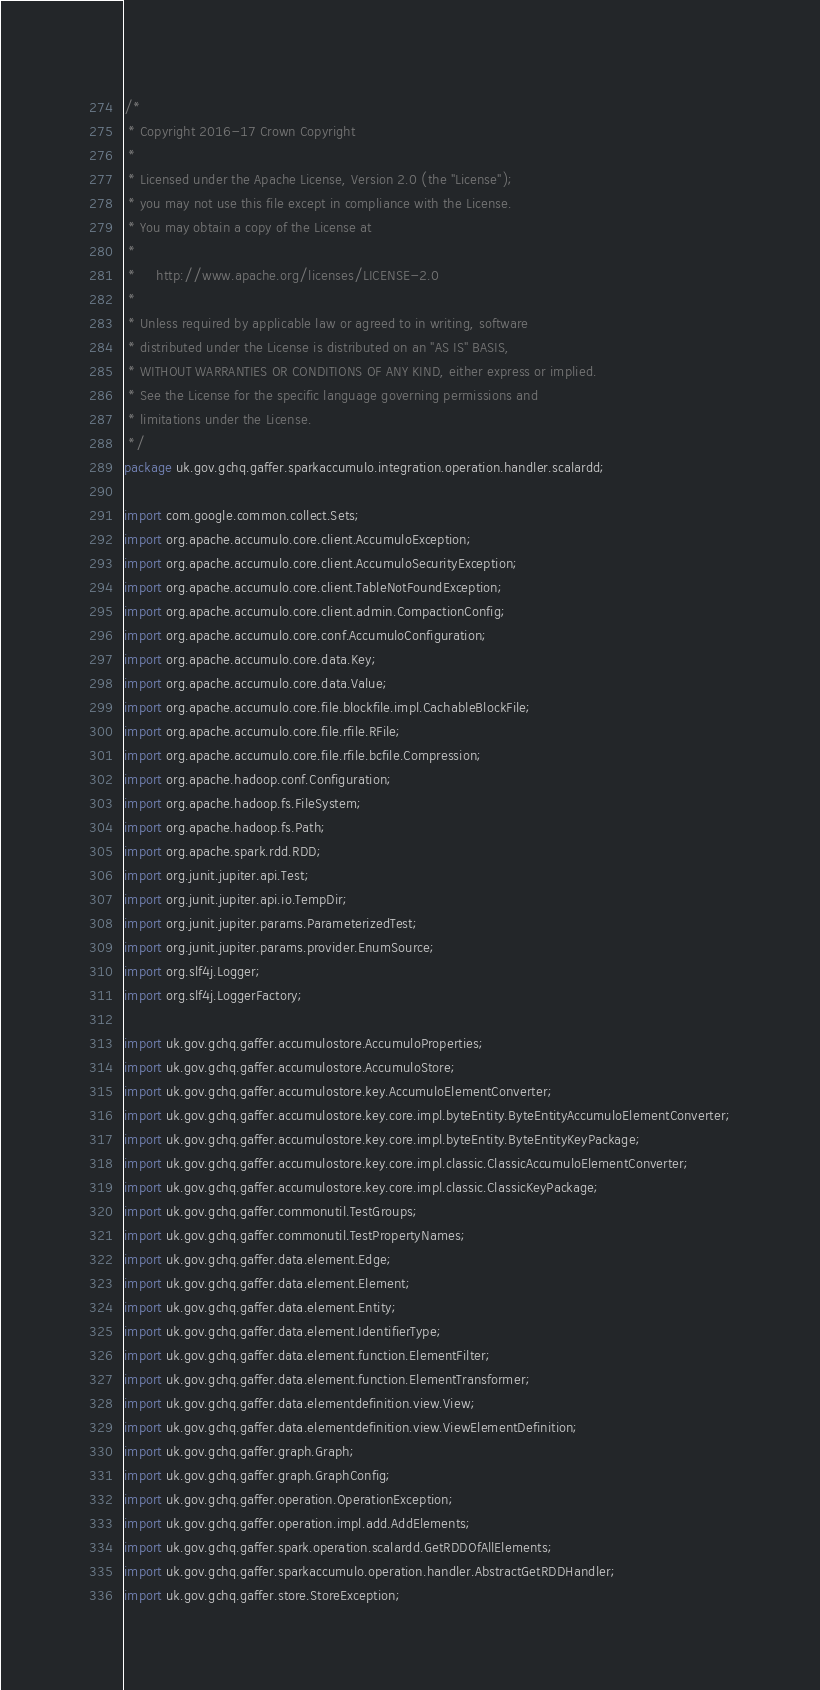<code> <loc_0><loc_0><loc_500><loc_500><_Java_>/*
 * Copyright 2016-17 Crown Copyright
 *
 * Licensed under the Apache License, Version 2.0 (the "License");
 * you may not use this file except in compliance with the License.
 * You may obtain a copy of the License at
 *
 *     http://www.apache.org/licenses/LICENSE-2.0
 *
 * Unless required by applicable law or agreed to in writing, software
 * distributed under the License is distributed on an "AS IS" BASIS,
 * WITHOUT WARRANTIES OR CONDITIONS OF ANY KIND, either express or implied.
 * See the License for the specific language governing permissions and
 * limitations under the License.
 */
package uk.gov.gchq.gaffer.sparkaccumulo.integration.operation.handler.scalardd;

import com.google.common.collect.Sets;
import org.apache.accumulo.core.client.AccumuloException;
import org.apache.accumulo.core.client.AccumuloSecurityException;
import org.apache.accumulo.core.client.TableNotFoundException;
import org.apache.accumulo.core.client.admin.CompactionConfig;
import org.apache.accumulo.core.conf.AccumuloConfiguration;
import org.apache.accumulo.core.data.Key;
import org.apache.accumulo.core.data.Value;
import org.apache.accumulo.core.file.blockfile.impl.CachableBlockFile;
import org.apache.accumulo.core.file.rfile.RFile;
import org.apache.accumulo.core.file.rfile.bcfile.Compression;
import org.apache.hadoop.conf.Configuration;
import org.apache.hadoop.fs.FileSystem;
import org.apache.hadoop.fs.Path;
import org.apache.spark.rdd.RDD;
import org.junit.jupiter.api.Test;
import org.junit.jupiter.api.io.TempDir;
import org.junit.jupiter.params.ParameterizedTest;
import org.junit.jupiter.params.provider.EnumSource;
import org.slf4j.Logger;
import org.slf4j.LoggerFactory;

import uk.gov.gchq.gaffer.accumulostore.AccumuloProperties;
import uk.gov.gchq.gaffer.accumulostore.AccumuloStore;
import uk.gov.gchq.gaffer.accumulostore.key.AccumuloElementConverter;
import uk.gov.gchq.gaffer.accumulostore.key.core.impl.byteEntity.ByteEntityAccumuloElementConverter;
import uk.gov.gchq.gaffer.accumulostore.key.core.impl.byteEntity.ByteEntityKeyPackage;
import uk.gov.gchq.gaffer.accumulostore.key.core.impl.classic.ClassicAccumuloElementConverter;
import uk.gov.gchq.gaffer.accumulostore.key.core.impl.classic.ClassicKeyPackage;
import uk.gov.gchq.gaffer.commonutil.TestGroups;
import uk.gov.gchq.gaffer.commonutil.TestPropertyNames;
import uk.gov.gchq.gaffer.data.element.Edge;
import uk.gov.gchq.gaffer.data.element.Element;
import uk.gov.gchq.gaffer.data.element.Entity;
import uk.gov.gchq.gaffer.data.element.IdentifierType;
import uk.gov.gchq.gaffer.data.element.function.ElementFilter;
import uk.gov.gchq.gaffer.data.element.function.ElementTransformer;
import uk.gov.gchq.gaffer.data.elementdefinition.view.View;
import uk.gov.gchq.gaffer.data.elementdefinition.view.ViewElementDefinition;
import uk.gov.gchq.gaffer.graph.Graph;
import uk.gov.gchq.gaffer.graph.GraphConfig;
import uk.gov.gchq.gaffer.operation.OperationException;
import uk.gov.gchq.gaffer.operation.impl.add.AddElements;
import uk.gov.gchq.gaffer.spark.operation.scalardd.GetRDDOfAllElements;
import uk.gov.gchq.gaffer.sparkaccumulo.operation.handler.AbstractGetRDDHandler;
import uk.gov.gchq.gaffer.store.StoreException;</code> 